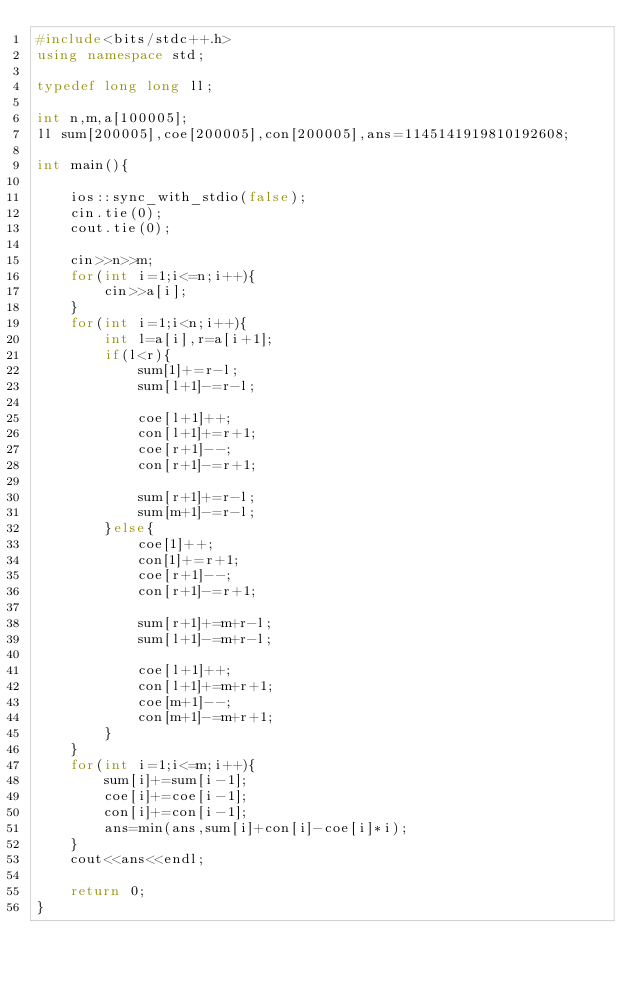Convert code to text. <code><loc_0><loc_0><loc_500><loc_500><_C++_>#include<bits/stdc++.h>
using namespace std;

typedef long long ll;

int n,m,a[100005];
ll sum[200005],coe[200005],con[200005],ans=1145141919810192608;

int main(){

    ios::sync_with_stdio(false);
    cin.tie(0);
    cout.tie(0);

    cin>>n>>m;
    for(int i=1;i<=n;i++){
        cin>>a[i];
    }
    for(int i=1;i<n;i++){
        int l=a[i],r=a[i+1];
        if(l<r){
            sum[1]+=r-l;
            sum[l+1]-=r-l;

            coe[l+1]++;
            con[l+1]+=r+1;
            coe[r+1]--;
            con[r+1]-=r+1;

            sum[r+1]+=r-l;
            sum[m+1]-=r-l;
        }else{
            coe[1]++;
            con[1]+=r+1;
            coe[r+1]--;
            con[r+1]-=r+1;

            sum[r+1]+=m+r-l;
            sum[l+1]-=m+r-l;

            coe[l+1]++;
            con[l+1]+=m+r+1;
            coe[m+1]--;
            con[m+1]-=m+r+1;
        }
    }
    for(int i=1;i<=m;i++){
        sum[i]+=sum[i-1];
        coe[i]+=coe[i-1];
        con[i]+=con[i-1];
        ans=min(ans,sum[i]+con[i]-coe[i]*i);
    }
    cout<<ans<<endl;

    return 0;
}</code> 